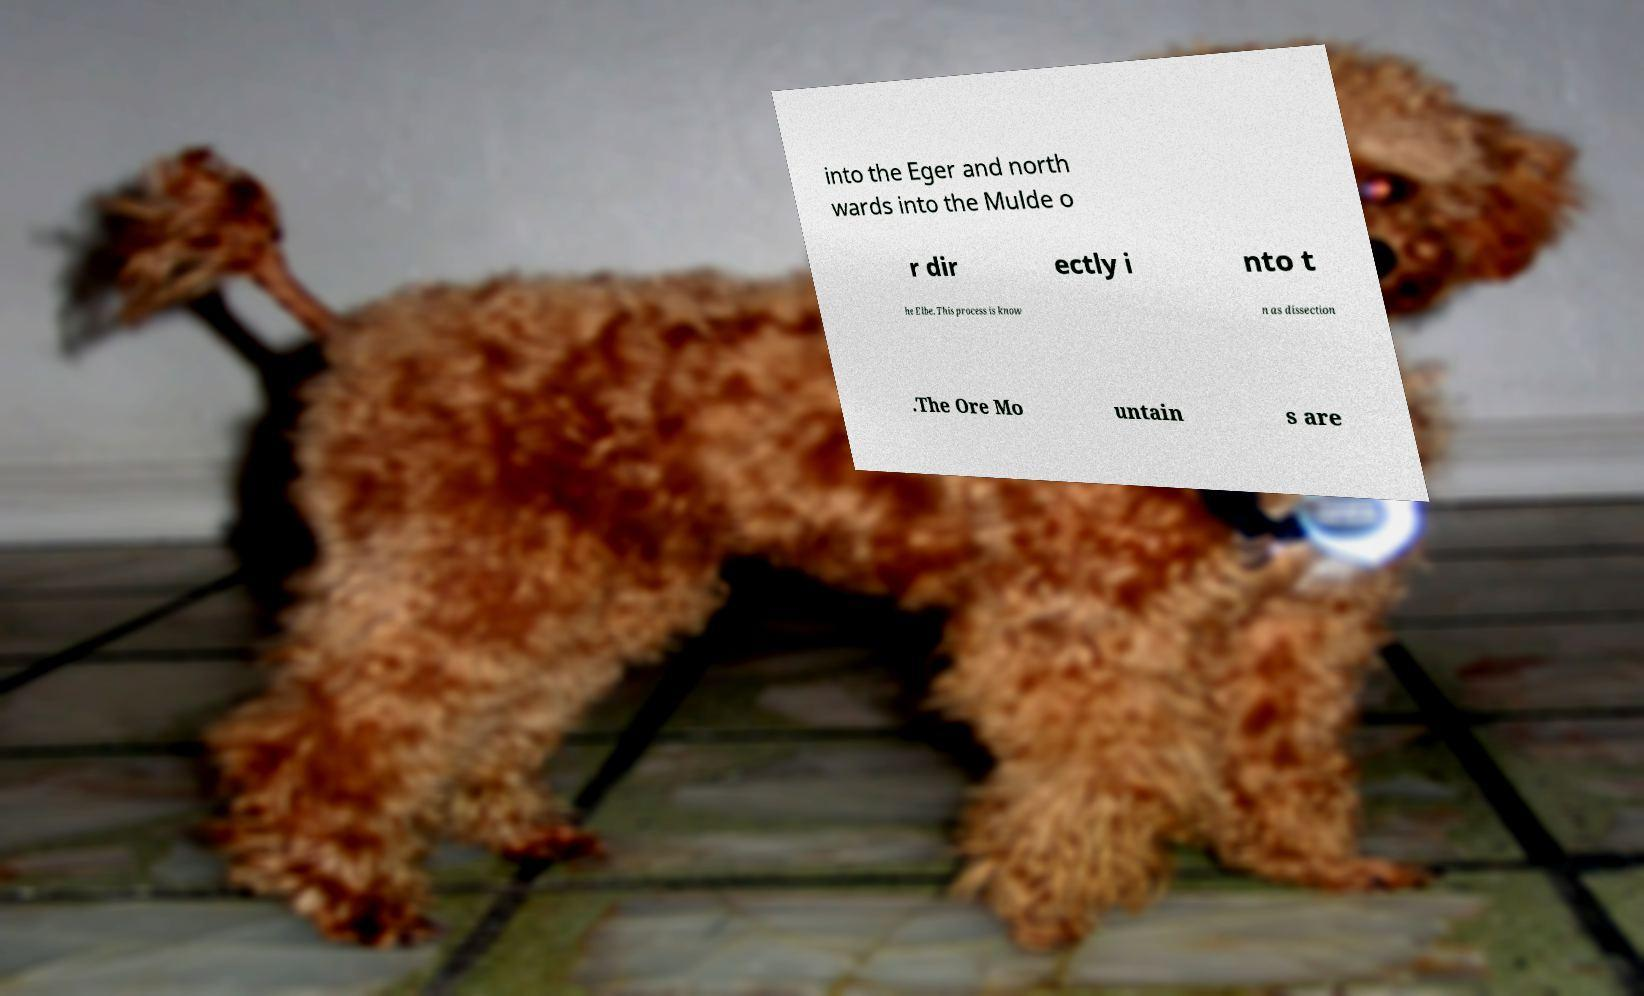Could you assist in decoding the text presented in this image and type it out clearly? into the Eger and north wards into the Mulde o r dir ectly i nto t he Elbe. This process is know n as dissection .The Ore Mo untain s are 